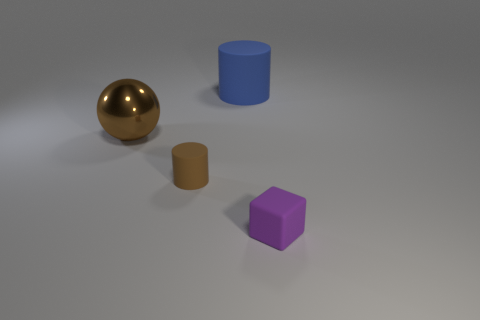Are there more purple things that are on the right side of the brown ball than blue rubber objects that are left of the blue thing?
Provide a succinct answer. Yes. What color is the rubber cylinder that is the same size as the brown metallic thing?
Your response must be concise. Blue. Are there any small cylinders of the same color as the metallic sphere?
Your response must be concise. Yes. Does the big object that is behind the big shiny sphere have the same color as the small object that is behind the small purple cube?
Keep it short and to the point. No. There is a cylinder behind the tiny brown matte cylinder; what is it made of?
Offer a very short reply. Rubber. What is the color of the cylinder that is made of the same material as the blue thing?
Ensure brevity in your answer.  Brown. How many gray objects are the same size as the ball?
Provide a short and direct response. 0. There is a cylinder on the left side of the blue cylinder; is it the same size as the large blue thing?
Your answer should be compact. No. There is a thing that is both on the left side of the large matte cylinder and in front of the large brown metallic object; what shape is it?
Make the answer very short. Cylinder. There is a tiny purple matte thing; are there any blocks in front of it?
Make the answer very short. No. 